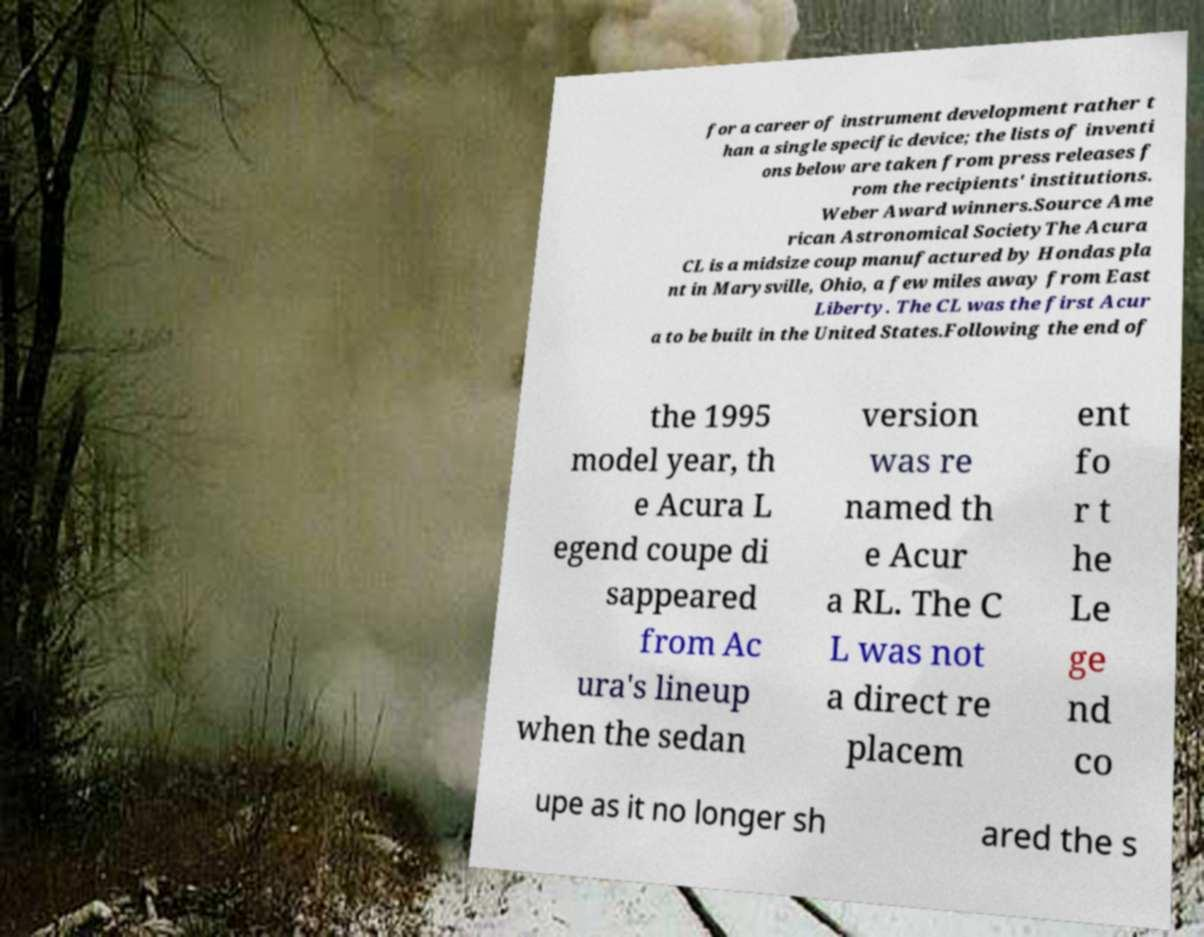Can you accurately transcribe the text from the provided image for me? for a career of instrument development rather t han a single specific device; the lists of inventi ons below are taken from press releases f rom the recipients' institutions. Weber Award winners.Source Ame rican Astronomical SocietyThe Acura CL is a midsize coup manufactured by Hondas pla nt in Marysville, Ohio, a few miles away from East Liberty. The CL was the first Acur a to be built in the United States.Following the end of the 1995 model year, th e Acura L egend coupe di sappeared from Ac ura's lineup when the sedan version was re named th e Acur a RL. The C L was not a direct re placem ent fo r t he Le ge nd co upe as it no longer sh ared the s 